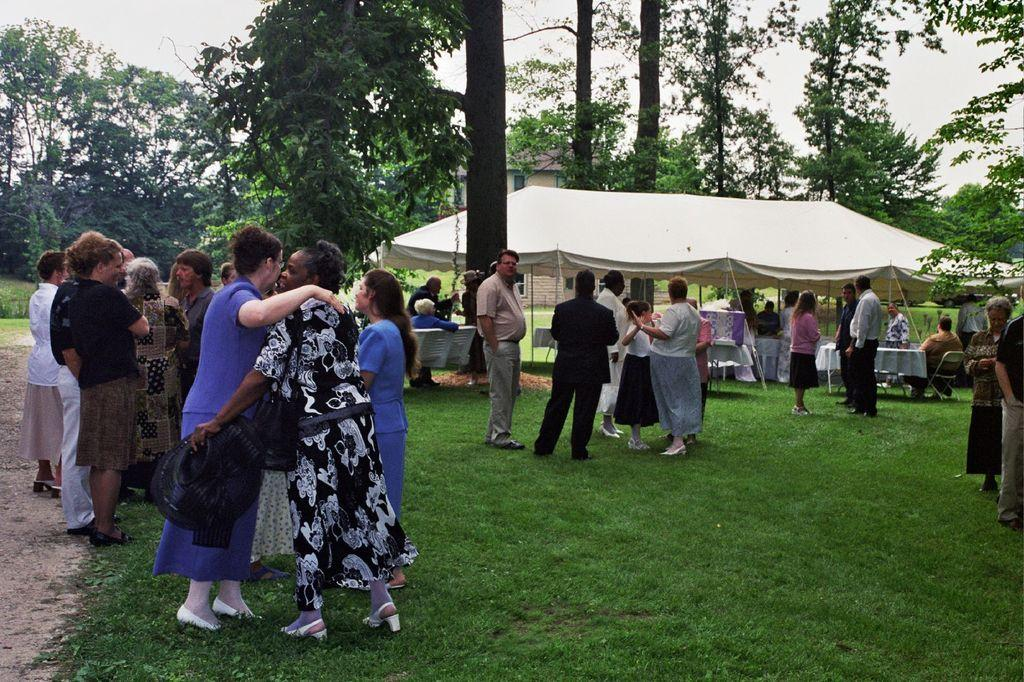What are the people in the image doing? Some people are standing on the ground, while others are sitting on chairs or benches. What can be seen in the background of the image? There are trees, buildings, a tent, and the sky visible in the background. Can you tell me how many volleyballs are being used in the image? There are no volleyballs present in the image. What type of road can be seen in the image? There is no road visible in the image. 